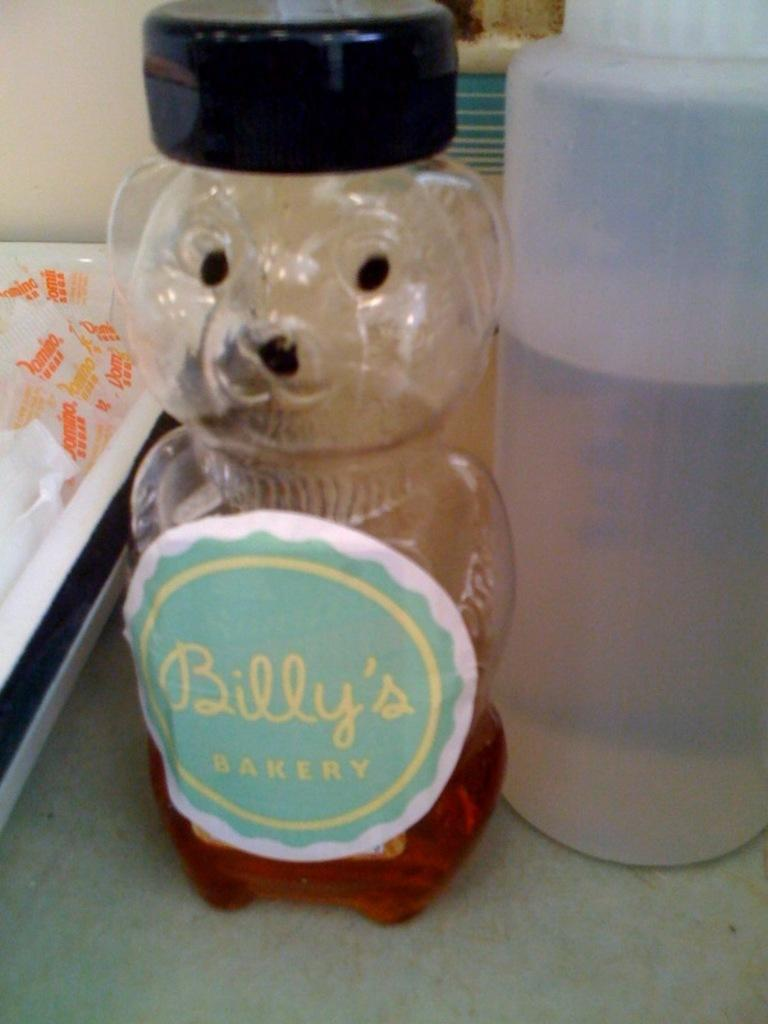What object can be seen in the image? There is a bottle in the image. What is written on the bottle? The word "Billy's" is written on the bottle. What type of light can be seen coming from the basketball in the image? There is no basketball present in the image, so there is no light coming from a basketball. 